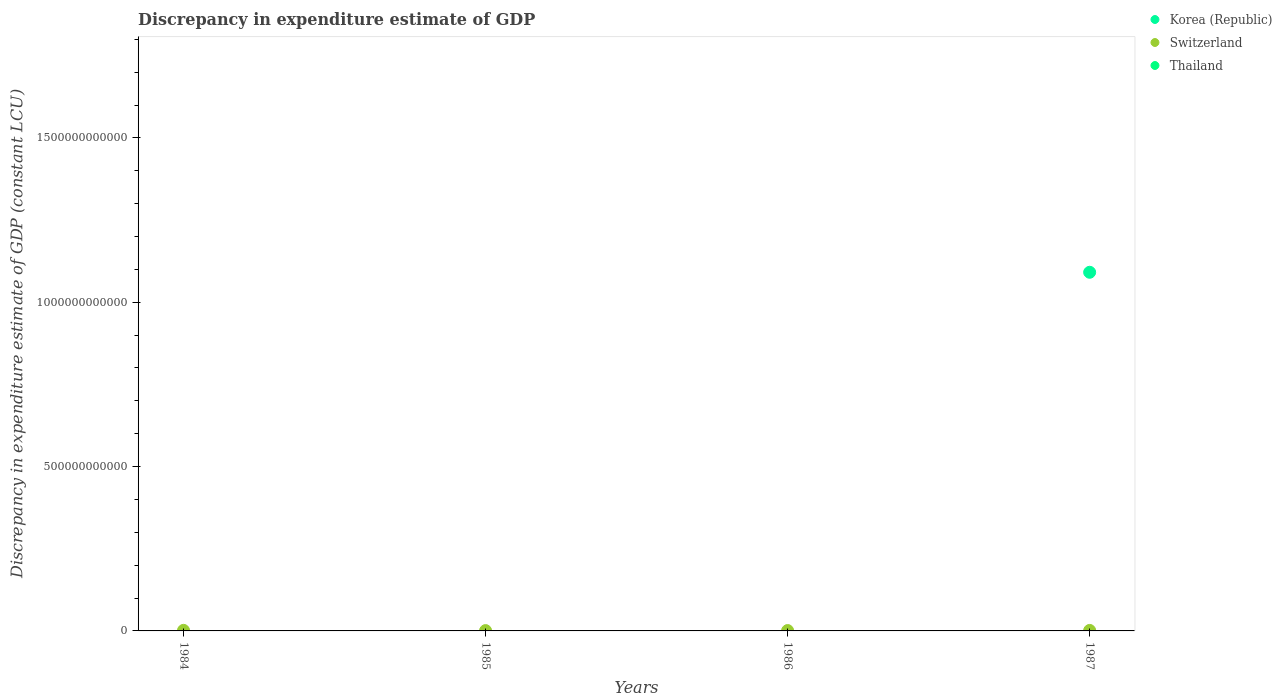How many different coloured dotlines are there?
Make the answer very short. 2. Is the number of dotlines equal to the number of legend labels?
Provide a short and direct response. No. What is the discrepancy in expenditure estimate of GDP in Thailand in 1984?
Offer a very short reply. 0. Across all years, what is the maximum discrepancy in expenditure estimate of GDP in Korea (Republic)?
Keep it short and to the point. 1.09e+12. Across all years, what is the minimum discrepancy in expenditure estimate of GDP in Korea (Republic)?
Your answer should be compact. 0. In which year was the discrepancy in expenditure estimate of GDP in Korea (Republic) maximum?
Make the answer very short. 1987. What is the total discrepancy in expenditure estimate of GDP in Switzerland in the graph?
Give a very brief answer. 5.37e+09. What is the difference between the discrepancy in expenditure estimate of GDP in Switzerland in 1985 and that in 1986?
Make the answer very short. -1.28e+08. What is the difference between the discrepancy in expenditure estimate of GDP in Thailand in 1985 and the discrepancy in expenditure estimate of GDP in Korea (Republic) in 1987?
Provide a short and direct response. -1.09e+12. What is the average discrepancy in expenditure estimate of GDP in Switzerland per year?
Your response must be concise. 1.34e+09. What is the ratio of the discrepancy in expenditure estimate of GDP in Switzerland in 1984 to that in 1985?
Offer a very short reply. 1.72. What is the difference between the highest and the second highest discrepancy in expenditure estimate of GDP in Switzerland?
Ensure brevity in your answer.  2.15e+08. What is the difference between the highest and the lowest discrepancy in expenditure estimate of GDP in Switzerland?
Your response must be concise. 7.23e+08. In how many years, is the discrepancy in expenditure estimate of GDP in Switzerland greater than the average discrepancy in expenditure estimate of GDP in Switzerland taken over all years?
Your response must be concise. 2. Does the discrepancy in expenditure estimate of GDP in Switzerland monotonically increase over the years?
Provide a short and direct response. No. Is the discrepancy in expenditure estimate of GDP in Thailand strictly greater than the discrepancy in expenditure estimate of GDP in Korea (Republic) over the years?
Provide a short and direct response. No. How many dotlines are there?
Offer a very short reply. 2. How many years are there in the graph?
Your response must be concise. 4. What is the difference between two consecutive major ticks on the Y-axis?
Your answer should be compact. 5.00e+11. Are the values on the major ticks of Y-axis written in scientific E-notation?
Give a very brief answer. No. Does the graph contain any zero values?
Make the answer very short. Yes. Does the graph contain grids?
Keep it short and to the point. No. Where does the legend appear in the graph?
Your answer should be very brief. Top right. How many legend labels are there?
Give a very brief answer. 3. How are the legend labels stacked?
Provide a succinct answer. Vertical. What is the title of the graph?
Your answer should be very brief. Discrepancy in expenditure estimate of GDP. What is the label or title of the X-axis?
Give a very brief answer. Years. What is the label or title of the Y-axis?
Give a very brief answer. Discrepancy in expenditure estimate of GDP (constant LCU). What is the Discrepancy in expenditure estimate of GDP (constant LCU) of Switzerland in 1984?
Your answer should be compact. 1.72e+09. What is the Discrepancy in expenditure estimate of GDP (constant LCU) of Switzerland in 1985?
Make the answer very short. 1.00e+09. What is the Discrepancy in expenditure estimate of GDP (constant LCU) of Korea (Republic) in 1986?
Offer a very short reply. 0. What is the Discrepancy in expenditure estimate of GDP (constant LCU) of Switzerland in 1986?
Offer a very short reply. 1.13e+09. What is the Discrepancy in expenditure estimate of GDP (constant LCU) in Thailand in 1986?
Offer a terse response. 0. What is the Discrepancy in expenditure estimate of GDP (constant LCU) of Korea (Republic) in 1987?
Your answer should be compact. 1.09e+12. What is the Discrepancy in expenditure estimate of GDP (constant LCU) in Switzerland in 1987?
Make the answer very short. 1.51e+09. What is the Discrepancy in expenditure estimate of GDP (constant LCU) in Thailand in 1987?
Ensure brevity in your answer.  0. Across all years, what is the maximum Discrepancy in expenditure estimate of GDP (constant LCU) of Korea (Republic)?
Offer a very short reply. 1.09e+12. Across all years, what is the maximum Discrepancy in expenditure estimate of GDP (constant LCU) of Switzerland?
Provide a succinct answer. 1.72e+09. Across all years, what is the minimum Discrepancy in expenditure estimate of GDP (constant LCU) of Switzerland?
Offer a terse response. 1.00e+09. What is the total Discrepancy in expenditure estimate of GDP (constant LCU) of Korea (Republic) in the graph?
Your answer should be very brief. 1.09e+12. What is the total Discrepancy in expenditure estimate of GDP (constant LCU) in Switzerland in the graph?
Give a very brief answer. 5.37e+09. What is the difference between the Discrepancy in expenditure estimate of GDP (constant LCU) of Switzerland in 1984 and that in 1985?
Provide a succinct answer. 7.23e+08. What is the difference between the Discrepancy in expenditure estimate of GDP (constant LCU) in Switzerland in 1984 and that in 1986?
Offer a very short reply. 5.95e+08. What is the difference between the Discrepancy in expenditure estimate of GDP (constant LCU) of Switzerland in 1984 and that in 1987?
Make the answer very short. 2.15e+08. What is the difference between the Discrepancy in expenditure estimate of GDP (constant LCU) in Switzerland in 1985 and that in 1986?
Ensure brevity in your answer.  -1.28e+08. What is the difference between the Discrepancy in expenditure estimate of GDP (constant LCU) in Switzerland in 1985 and that in 1987?
Offer a terse response. -5.08e+08. What is the difference between the Discrepancy in expenditure estimate of GDP (constant LCU) in Switzerland in 1986 and that in 1987?
Provide a short and direct response. -3.80e+08. What is the average Discrepancy in expenditure estimate of GDP (constant LCU) of Korea (Republic) per year?
Your response must be concise. 2.73e+11. What is the average Discrepancy in expenditure estimate of GDP (constant LCU) of Switzerland per year?
Your answer should be compact. 1.34e+09. In the year 1987, what is the difference between the Discrepancy in expenditure estimate of GDP (constant LCU) of Korea (Republic) and Discrepancy in expenditure estimate of GDP (constant LCU) of Switzerland?
Your answer should be compact. 1.09e+12. What is the ratio of the Discrepancy in expenditure estimate of GDP (constant LCU) of Switzerland in 1984 to that in 1985?
Offer a very short reply. 1.72. What is the ratio of the Discrepancy in expenditure estimate of GDP (constant LCU) of Switzerland in 1984 to that in 1986?
Keep it short and to the point. 1.53. What is the ratio of the Discrepancy in expenditure estimate of GDP (constant LCU) of Switzerland in 1984 to that in 1987?
Your answer should be compact. 1.14. What is the ratio of the Discrepancy in expenditure estimate of GDP (constant LCU) of Switzerland in 1985 to that in 1986?
Offer a very short reply. 0.89. What is the ratio of the Discrepancy in expenditure estimate of GDP (constant LCU) in Switzerland in 1985 to that in 1987?
Your answer should be very brief. 0.66. What is the ratio of the Discrepancy in expenditure estimate of GDP (constant LCU) in Switzerland in 1986 to that in 1987?
Ensure brevity in your answer.  0.75. What is the difference between the highest and the second highest Discrepancy in expenditure estimate of GDP (constant LCU) of Switzerland?
Offer a very short reply. 2.15e+08. What is the difference between the highest and the lowest Discrepancy in expenditure estimate of GDP (constant LCU) of Korea (Republic)?
Keep it short and to the point. 1.09e+12. What is the difference between the highest and the lowest Discrepancy in expenditure estimate of GDP (constant LCU) in Switzerland?
Your answer should be compact. 7.23e+08. 